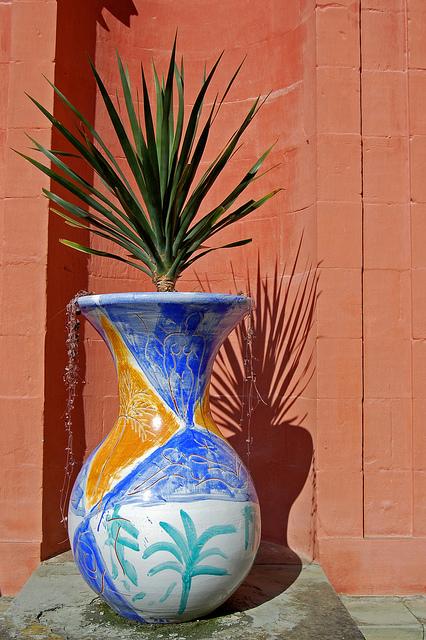Is this a palm tree growing in a vase?
Short answer required. Yes. What color is the wall?
Write a very short answer. Brown. What color is the vase?
Be succinct. Blue. 